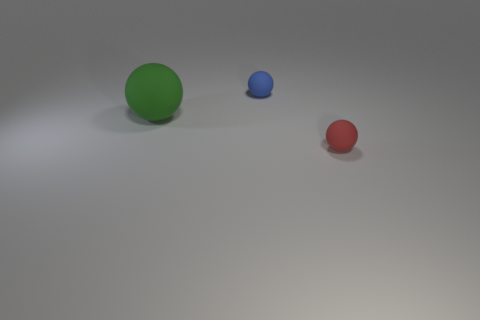Subtract 1 spheres. How many spheres are left? 2 Add 2 cyan metal cubes. How many objects exist? 5 Subtract all purple balls. Subtract all purple cylinders. How many balls are left? 3 Add 1 tiny spheres. How many tiny spheres are left? 3 Add 1 big yellow rubber cylinders. How many big yellow rubber cylinders exist? 1 Subtract 0 cyan spheres. How many objects are left? 3 Subtract all green balls. Subtract all green rubber things. How many objects are left? 1 